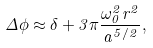Convert formula to latex. <formula><loc_0><loc_0><loc_500><loc_500>\Delta \phi \approx \delta + 3 \pi \frac { \omega _ { 0 } ^ { 2 } r ^ { 2 } } { a ^ { 5 / 2 } } ,</formula> 